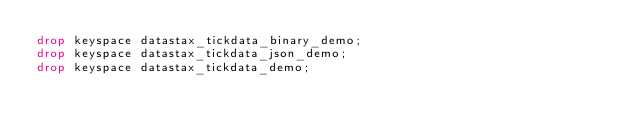Convert code to text. <code><loc_0><loc_0><loc_500><loc_500><_SQL_>drop keyspace datastax_tickdata_binary_demo;
drop keyspace datastax_tickdata_json_demo;
drop keyspace datastax_tickdata_demo;</code> 